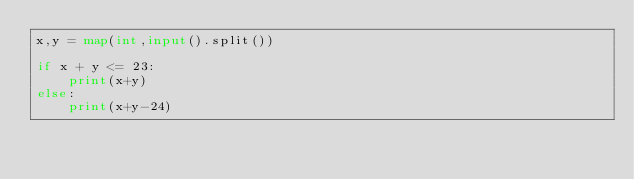Convert code to text. <code><loc_0><loc_0><loc_500><loc_500><_Python_>x,y = map(int,input().split())

if x + y <= 23:
    print(x+y)
else:
    print(x+y-24)</code> 